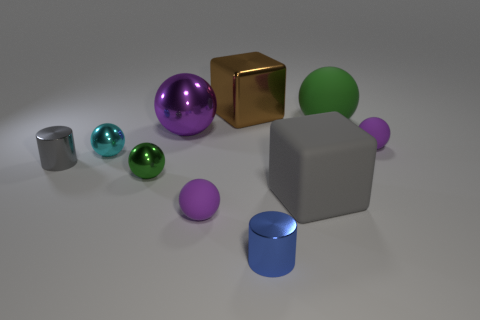What material is the purple object that is both in front of the big purple ball and left of the big gray cube?
Your response must be concise. Rubber. Do the tiny cyan object and the small purple matte object that is right of the blue metal cylinder have the same shape?
Provide a succinct answer. Yes. What material is the green ball that is behind the purple ball to the right of the thing that is behind the green rubber ball?
Provide a short and direct response. Rubber. What number of other objects are the same size as the cyan metallic sphere?
Offer a terse response. 5. There is a large matte object that is in front of the small purple rubber thing behind the cyan shiny sphere; what number of tiny balls are to the left of it?
Provide a short and direct response. 3. The tiny purple object that is in front of the small purple rubber thing that is behind the green shiny ball is made of what material?
Your answer should be very brief. Rubber. Are there any blue things that have the same shape as the gray shiny thing?
Make the answer very short. Yes. What color is the other block that is the same size as the matte cube?
Your response must be concise. Brown. How many things are purple rubber objects behind the green metallic ball or metallic things that are on the right side of the purple metal ball?
Your answer should be compact. 3. What number of things are large objects or big purple metallic spheres?
Your answer should be very brief. 4. 